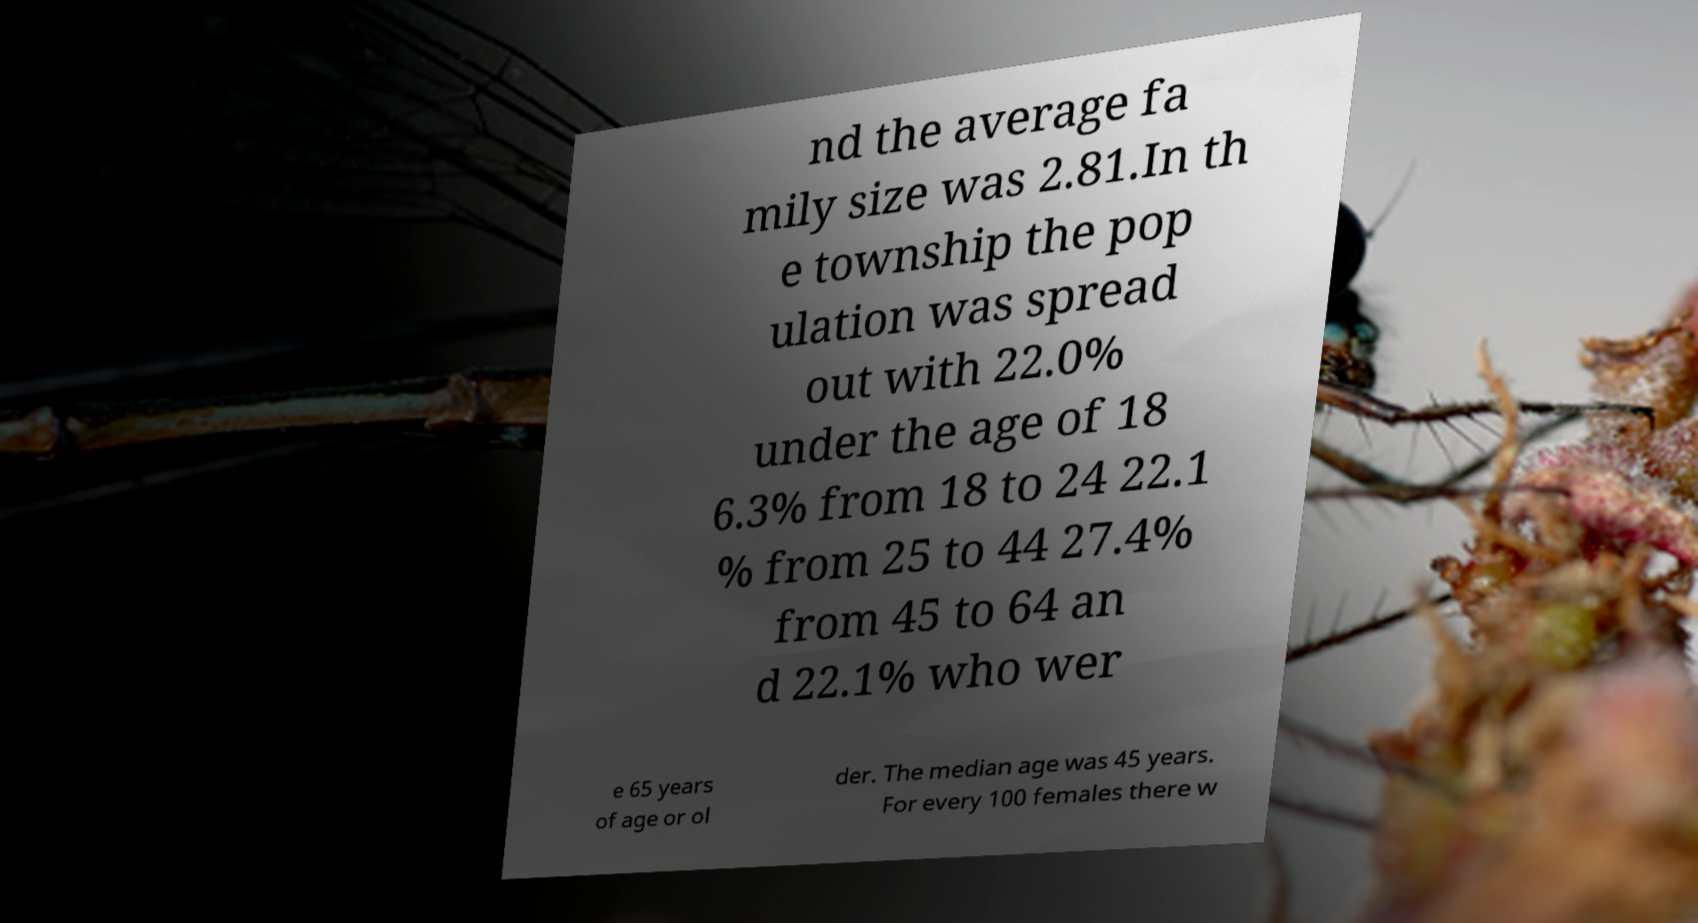Could you extract and type out the text from this image? nd the average fa mily size was 2.81.In th e township the pop ulation was spread out with 22.0% under the age of 18 6.3% from 18 to 24 22.1 % from 25 to 44 27.4% from 45 to 64 an d 22.1% who wer e 65 years of age or ol der. The median age was 45 years. For every 100 females there w 